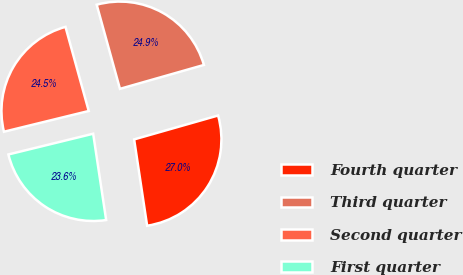Convert chart. <chart><loc_0><loc_0><loc_500><loc_500><pie_chart><fcel>Fourth quarter<fcel>Third quarter<fcel>Second quarter<fcel>First quarter<nl><fcel>27.04%<fcel>24.88%<fcel>24.53%<fcel>23.56%<nl></chart> 